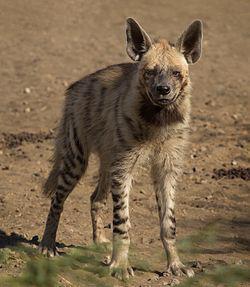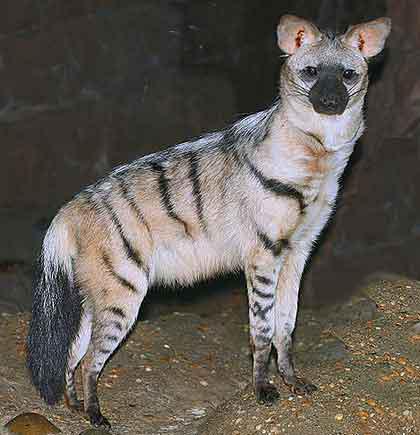The first image is the image on the left, the second image is the image on the right. Examine the images to the left and right. Is the description "there is exactly one animal lying down in one of the images" accurate? Answer yes or no. No. The first image is the image on the left, the second image is the image on the right. For the images shown, is this caption "A hyena has its body and face turned toward the camera." true? Answer yes or no. Yes. 